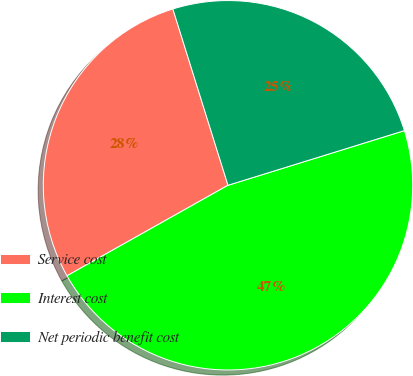Convert chart to OTSL. <chart><loc_0><loc_0><loc_500><loc_500><pie_chart><fcel>Service cost<fcel>Interest cost<fcel>Net periodic benefit cost<nl><fcel>28.33%<fcel>46.63%<fcel>25.04%<nl></chart> 